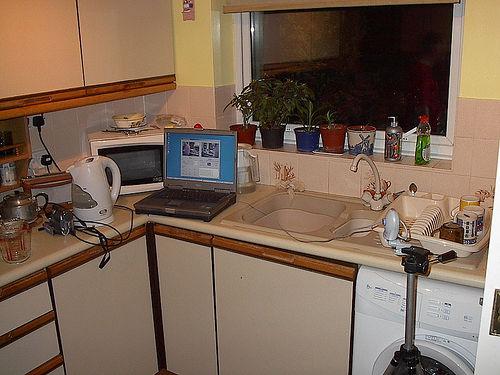Where is this?
Write a very short answer. Kitchen. Does someone like alcohol?
Write a very short answer. No. What color are the flowers on the counter?
Give a very brief answer. Green. What color is the shortest bottle?
Give a very brief answer. Silver. What color glass is in the dish drainer?
Concise answer only. White. How many upper level cabinets are there?
Answer briefly. 2. How many plants are there?
Be succinct. 4. How many plants do they have?
Short answer required. 5. What room in a house is this?
Write a very short answer. Kitchen. Is the laptop on?
Keep it brief. Yes. Does this kitchen need updated?
Concise answer only. Yes. What brand of soap is visible?
Answer briefly. Palmolive. 